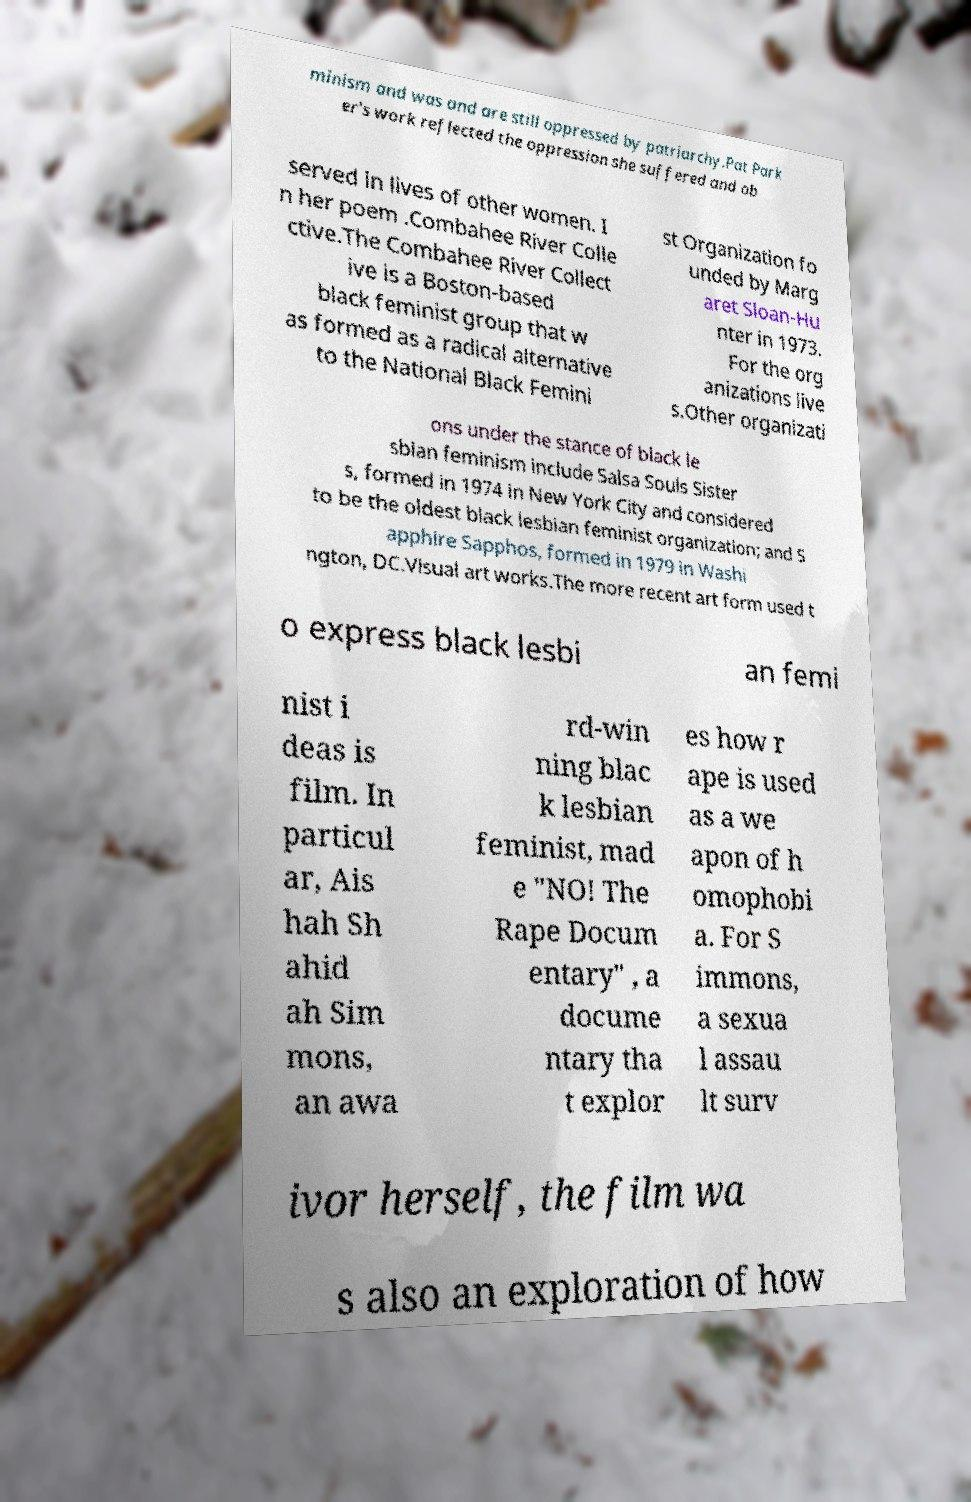Could you extract and type out the text from this image? minism and was and are still oppressed by patriarchy.Pat Park er's work reflected the oppression she suffered and ob served in lives of other women. I n her poem .Combahee River Colle ctive.The Combahee River Collect ive is a Boston-based black feminist group that w as formed as a radical alternative to the National Black Femini st Organization fo unded by Marg aret Sloan-Hu nter in 1973. For the org anizations live s.Other organizati ons under the stance of black le sbian feminism include Salsa Souls Sister s, formed in 1974 in New York City and considered to be the oldest black lesbian feminist organization; and S apphire Sapphos, formed in 1979 in Washi ngton, DC.Visual art works.The more recent art form used t o express black lesbi an femi nist i deas is film. In particul ar, Ais hah Sh ahid ah Sim mons, an awa rd-win ning blac k lesbian feminist, mad e "NO! The Rape Docum entary" , a docume ntary tha t explor es how r ape is used as a we apon of h omophobi a. For S immons, a sexua l assau lt surv ivor herself, the film wa s also an exploration of how 